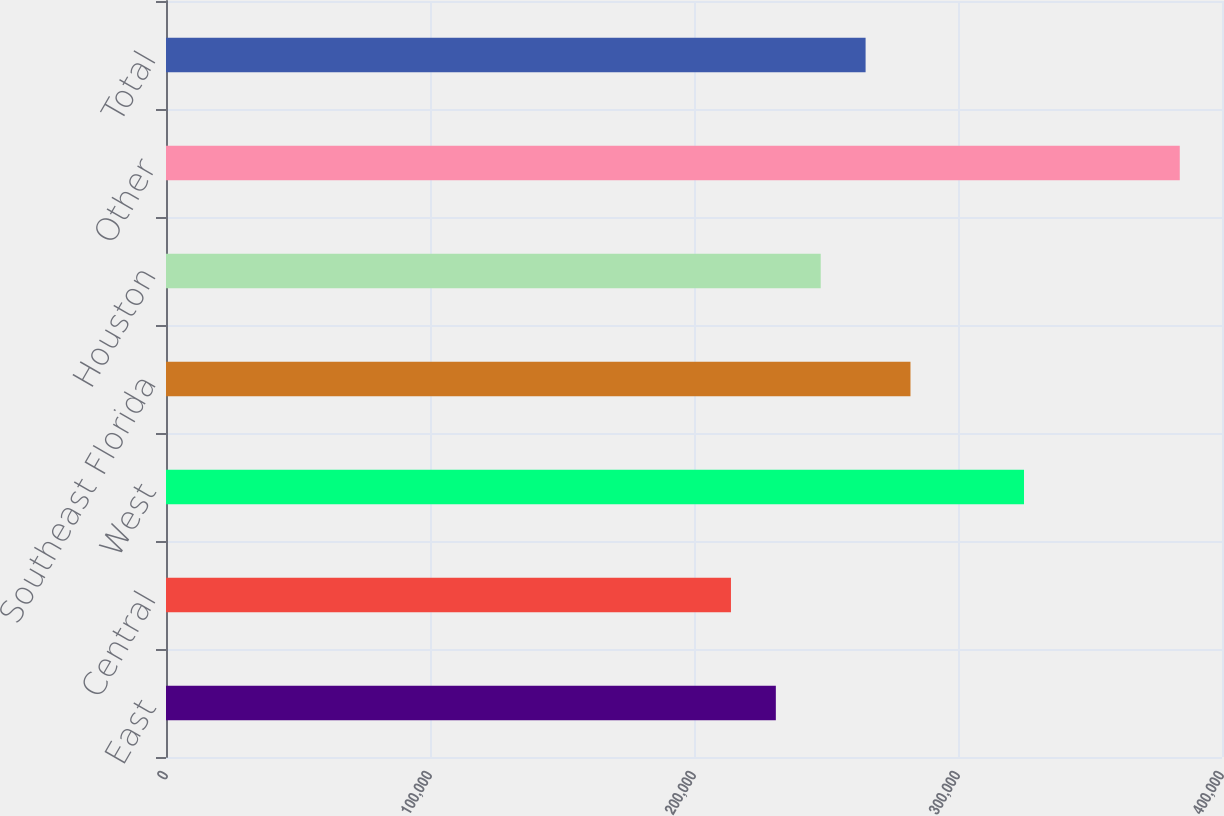Convert chart. <chart><loc_0><loc_0><loc_500><loc_500><bar_chart><fcel>East<fcel>Central<fcel>West<fcel>Southeast Florida<fcel>Houston<fcel>Other<fcel>Total<nl><fcel>231000<fcel>214000<fcel>325000<fcel>282000<fcel>248000<fcel>384000<fcel>265000<nl></chart> 